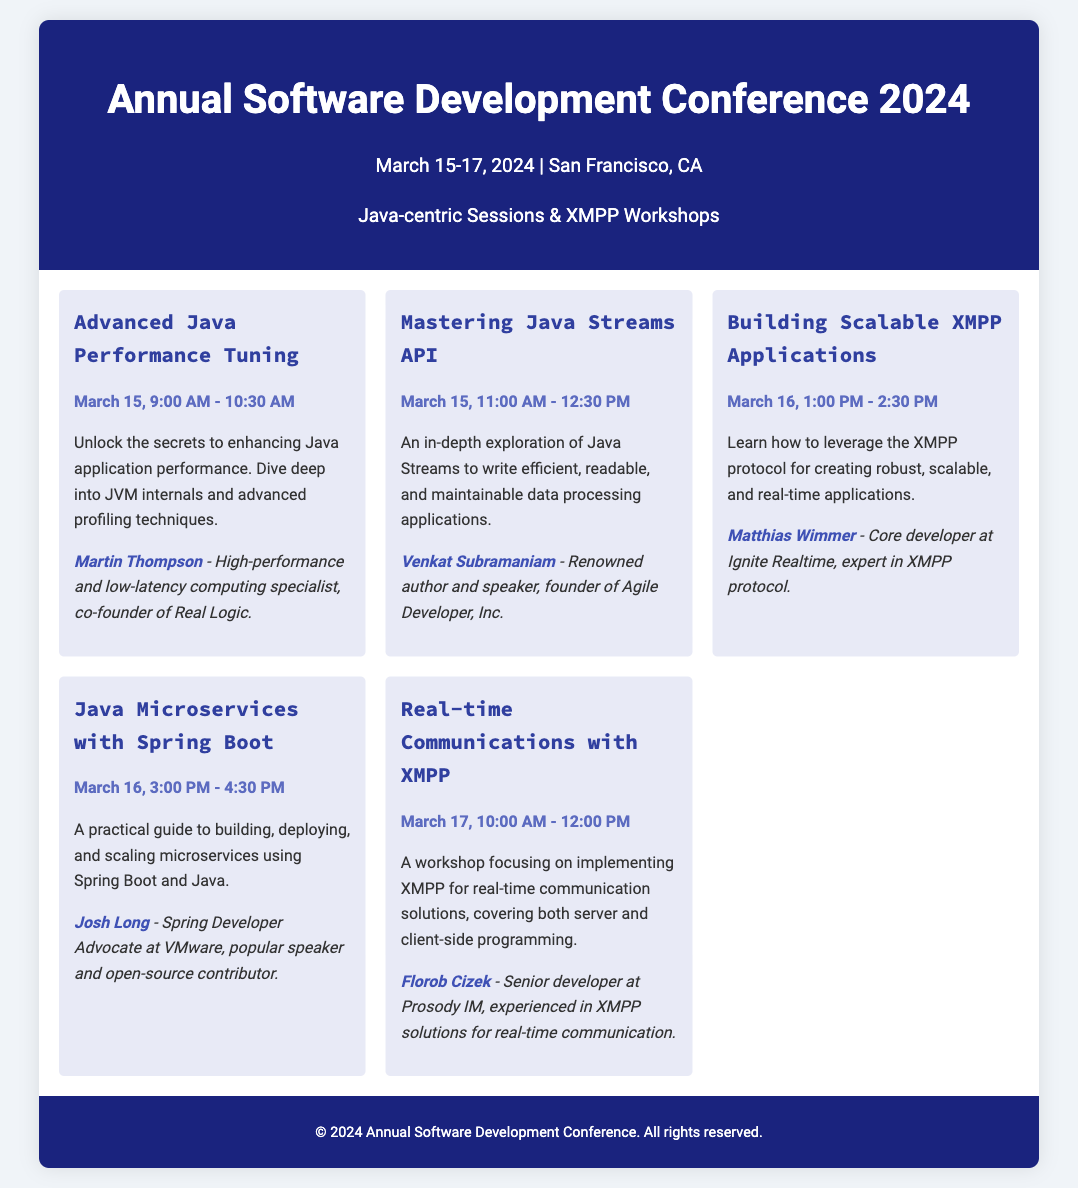What is the date of the conference? The conference is scheduled for March 15-17, 2024, as stated in the header.
Answer: March 15-17, 2024 Who is the speaker for the session on Java Microservices? The document lists Josh Long as the speaker for the Java Microservices session.
Answer: Josh Long What time does the "Advanced Java Performance Tuning" session start? The session is scheduled to begin at 9:00 AM on March 15, as indicated in the document.
Answer: 9:00 AM What session is focused on building scalable XMPP applications? The document explicitly mentions "Building Scalable XMPP Applications" as the relevant session.
Answer: Building Scalable XMPP Applications How long is the "Real-time Communications with XMPP" workshop? The duration of the workshop is stated to be 2 hours, from 10:00 AM to 12:00 PM on March 17.
Answer: 2 hours Which speaker is associated with XMPP? Matthias Wimmer is identified as an expert in the XMPP protocol.
Answer: Matthias Wimmer What is the theme of the conference highlighted in the description? The description emphasizes "Java-centric Sessions & XMPP Workshops."
Answer: Java-centric Sessions & XMPP Workshops Which session takes place directly after "Mastering Java Streams API"? The session on "Building Scalable XMPP Applications" follows the "Mastering Java Streams API" session.
Answer: Building Scalable XMPP Applications 